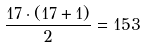<formula> <loc_0><loc_0><loc_500><loc_500>\frac { 1 7 \cdot ( 1 7 + 1 ) } { 2 } = 1 5 3</formula> 